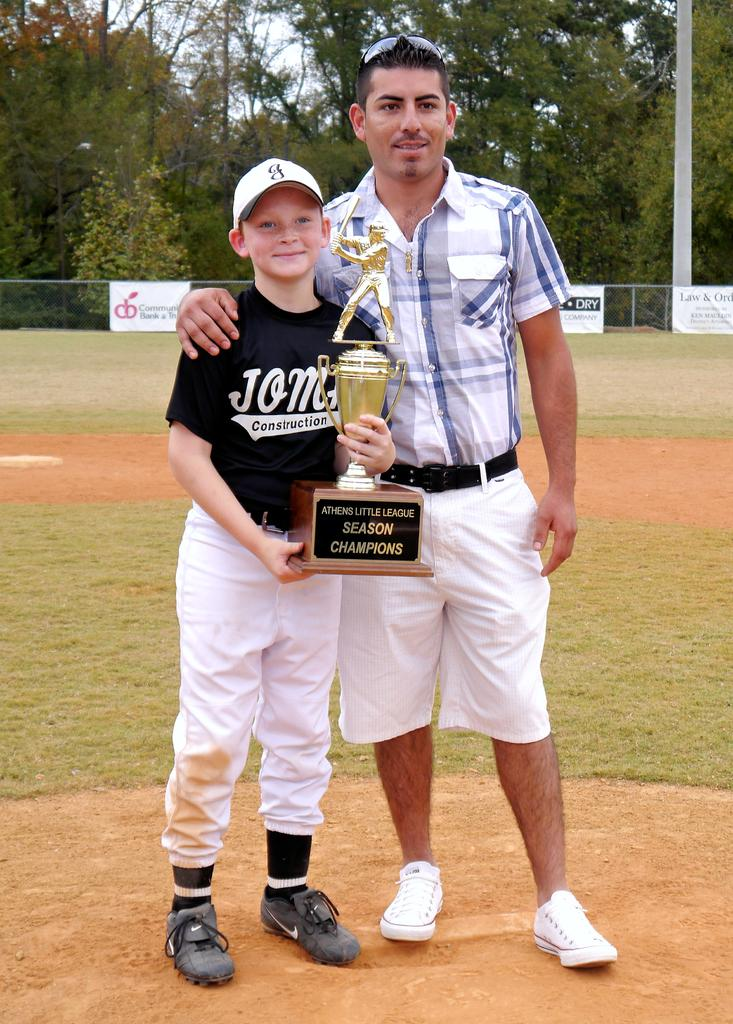<image>
Give a short and clear explanation of the subsequent image. A son and father holding a Little League Champions trophy. 